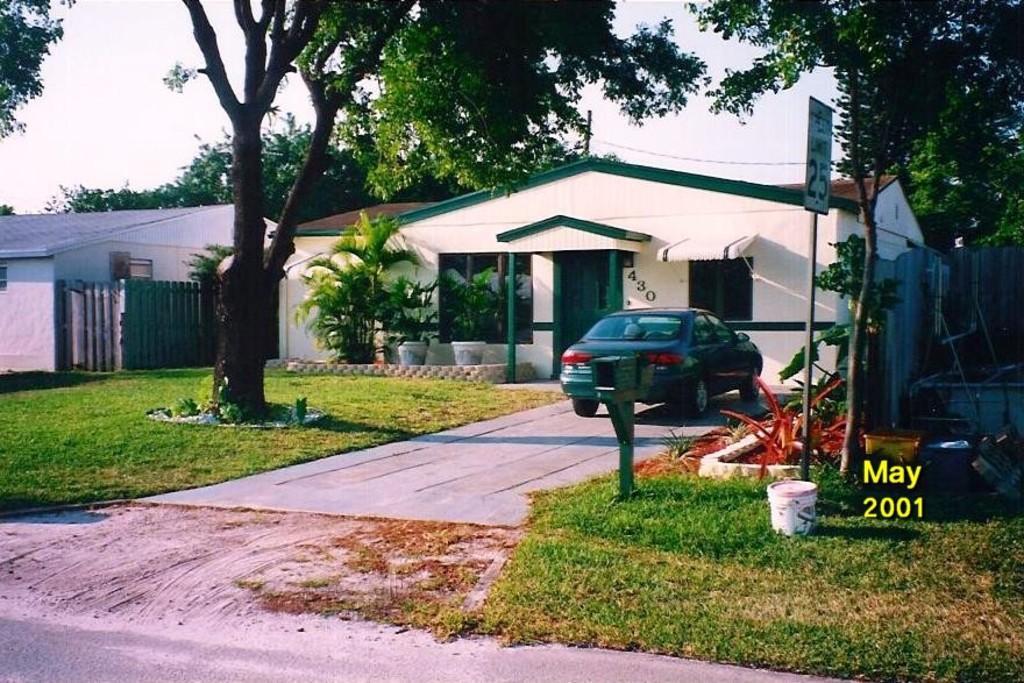Please provide a concise description of this image. This is an outside view. Here I can see two houses. In front of this house there are some house plants, tree and a car. On the right side, I can see some metal objects, board, tree and a bucket on the ground. Here I can see the green color grass. On the top of the image I can see the sky. At the left bottom of the image I can see the road. 